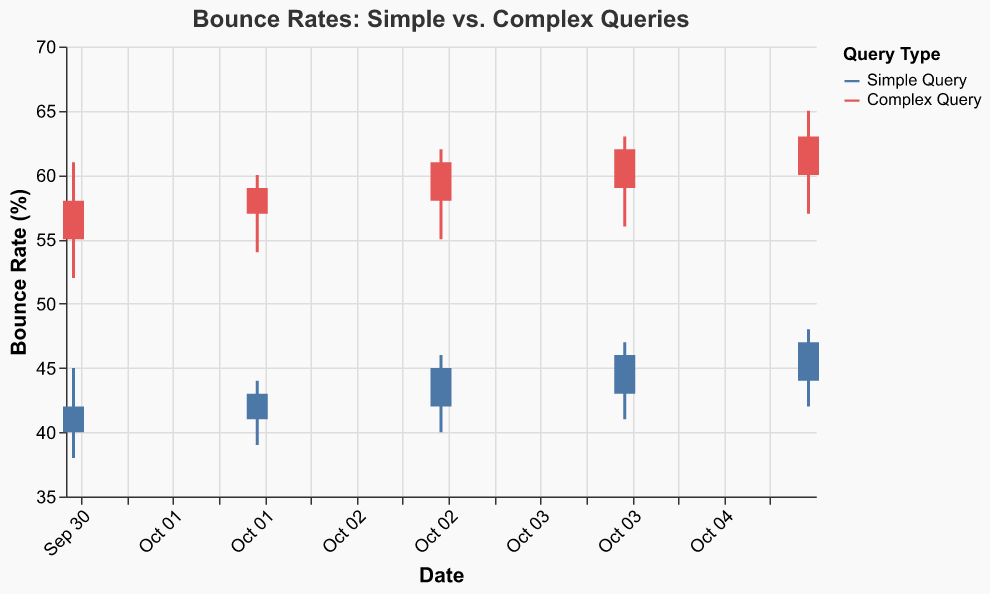What's the title of the chart? The title is located at the top of the chart and it reads "Bounce Rates: Simple vs. Complex Queries".
Answer: Bounce Rates: Simple vs. Complex Queries What is the date range of the data represented in the figure? The x-axis shows dates from "2023-10-01" to "2023-10-05."
Answer: 2023-10-01 to 2023-10-05 Which type of search generally has higher bounce rates, simple queries or complex queries? By observing the candlestick plot, we can see that the bounce rates for "Complex Query" are generally higher compared to "Simple Query" throughout the given dates.
Answer: Complex Query What was the highest bounce rate recorded for a simple query, and on what date did it occur? The highest bounce rate for a simple query is shown by the top of the candlestick representing the "High" value. For simple queries, this occurs on "2023-10-05" with a value of 48%.
Answer: 48% on 2023-10-05 How did the bounce rate for complex queries change from 2023-10-01 to 2023-10-05? By tracking the "Complex Query" candlesticks from 2023-10-01 to 2023-10-05, we see the closing rates are 58% (10-01), 59% (10-02), 61% (10-03), 62% (10-04), and 63% (10-05). Thus, the bounce rate increased over the given period.
Answer: Increased On which date do we see the smallest range in bounce rates for complex queries? The range in bounce rates can be observed by the distance between the "High" and "Low" values in the candlestick plot. The smallest range for complex queries occurs on 2023-10-02, where the difference is 6% (60 - 54).
Answer: 2023-10-02 What's the aggregate bounce rate change for simple queries over the given period? To find the aggregate change over the period, subtract the opening bounce rate on 2023-10-01 (40%) from the closing bounce rate on 2023-10-05 (47%). The change is 47% - 40% = 7%.
Answer: 7% Which type of query had the largest daily bounce rate increase and on which date? By comparing the opening and closing rates for each date, the largest daily increase appears for "Complex Query" on 2023-10-05, going from 60% (open) to 63% (close), an increase of 3%.
Answer: Complex Query on 2023-10-05 Which type of search showed more variability in bounce rates over the given period? Variability can be inferred from the length of the candlesticks and the range of highs and lows. "Complex Query" displays more variability with consistently larger candlesticks showing wider ranges between high and low values.
Answer: Complex Query 